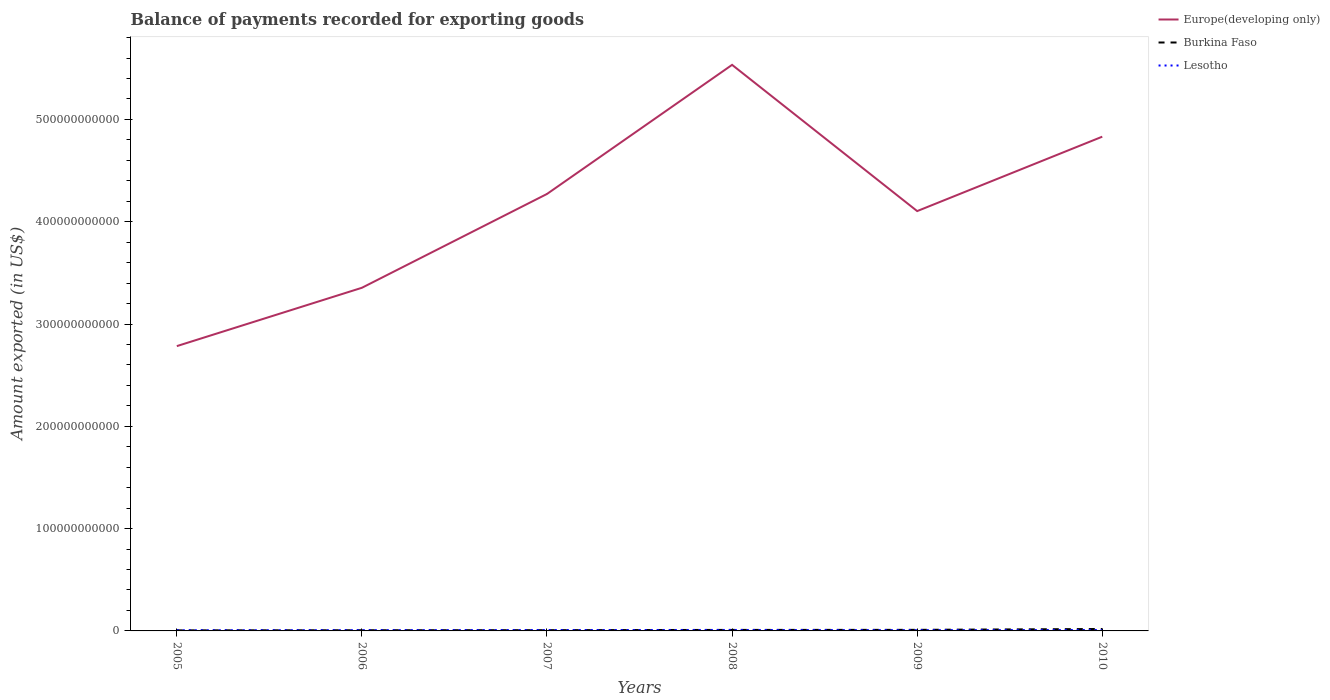Across all years, what is the maximum amount exported in Europe(developing only)?
Provide a short and direct response. 2.78e+11. In which year was the amount exported in Europe(developing only) maximum?
Keep it short and to the point. 2005. What is the total amount exported in Europe(developing only) in the graph?
Your answer should be compact. -5.70e+1. What is the difference between the highest and the second highest amount exported in Europe(developing only)?
Your answer should be very brief. 2.75e+11. Is the amount exported in Burkina Faso strictly greater than the amount exported in Europe(developing only) over the years?
Provide a short and direct response. Yes. How many lines are there?
Keep it short and to the point. 3. What is the difference between two consecutive major ticks on the Y-axis?
Your response must be concise. 1.00e+11. How many legend labels are there?
Ensure brevity in your answer.  3. How are the legend labels stacked?
Keep it short and to the point. Vertical. What is the title of the graph?
Offer a very short reply. Balance of payments recorded for exporting goods. Does "Korea (Republic)" appear as one of the legend labels in the graph?
Ensure brevity in your answer.  No. What is the label or title of the X-axis?
Make the answer very short. Years. What is the label or title of the Y-axis?
Make the answer very short. Amount exported (in US$). What is the Amount exported (in US$) in Europe(developing only) in 2005?
Keep it short and to the point. 2.78e+11. What is the Amount exported (in US$) in Burkina Faso in 2005?
Your answer should be very brief. 5.45e+08. What is the Amount exported (in US$) of Lesotho in 2005?
Your answer should be very brief. 6.68e+08. What is the Amount exported (in US$) in Europe(developing only) in 2006?
Offer a terse response. 3.35e+11. What is the Amount exported (in US$) in Burkina Faso in 2006?
Keep it short and to the point. 6.68e+08. What is the Amount exported (in US$) of Lesotho in 2006?
Offer a terse response. 7.57e+08. What is the Amount exported (in US$) of Europe(developing only) in 2007?
Ensure brevity in your answer.  4.27e+11. What is the Amount exported (in US$) in Burkina Faso in 2007?
Make the answer very short. 7.41e+08. What is the Amount exported (in US$) in Lesotho in 2007?
Your answer should be very brief. 8.72e+08. What is the Amount exported (in US$) in Europe(developing only) in 2008?
Provide a succinct answer. 5.53e+11. What is the Amount exported (in US$) in Burkina Faso in 2008?
Your response must be concise. 9.84e+08. What is the Amount exported (in US$) of Lesotho in 2008?
Give a very brief answer. 9.32e+08. What is the Amount exported (in US$) of Europe(developing only) in 2009?
Ensure brevity in your answer.  4.10e+11. What is the Amount exported (in US$) of Burkina Faso in 2009?
Your answer should be compact. 1.05e+09. What is the Amount exported (in US$) in Lesotho in 2009?
Keep it short and to the point. 7.76e+08. What is the Amount exported (in US$) in Europe(developing only) in 2010?
Your answer should be compact. 4.83e+11. What is the Amount exported (in US$) in Burkina Faso in 2010?
Provide a short and direct response. 1.89e+09. What is the Amount exported (in US$) of Lesotho in 2010?
Your response must be concise. 9.25e+08. Across all years, what is the maximum Amount exported (in US$) of Europe(developing only)?
Provide a short and direct response. 5.53e+11. Across all years, what is the maximum Amount exported (in US$) in Burkina Faso?
Ensure brevity in your answer.  1.89e+09. Across all years, what is the maximum Amount exported (in US$) in Lesotho?
Your response must be concise. 9.32e+08. Across all years, what is the minimum Amount exported (in US$) of Europe(developing only)?
Offer a terse response. 2.78e+11. Across all years, what is the minimum Amount exported (in US$) of Burkina Faso?
Give a very brief answer. 5.45e+08. Across all years, what is the minimum Amount exported (in US$) of Lesotho?
Your answer should be very brief. 6.68e+08. What is the total Amount exported (in US$) in Europe(developing only) in the graph?
Provide a short and direct response. 2.49e+12. What is the total Amount exported (in US$) in Burkina Faso in the graph?
Make the answer very short. 5.88e+09. What is the total Amount exported (in US$) of Lesotho in the graph?
Your response must be concise. 4.93e+09. What is the difference between the Amount exported (in US$) in Europe(developing only) in 2005 and that in 2006?
Your response must be concise. -5.70e+1. What is the difference between the Amount exported (in US$) in Burkina Faso in 2005 and that in 2006?
Offer a terse response. -1.22e+08. What is the difference between the Amount exported (in US$) of Lesotho in 2005 and that in 2006?
Your answer should be compact. -8.89e+07. What is the difference between the Amount exported (in US$) in Europe(developing only) in 2005 and that in 2007?
Your answer should be compact. -1.49e+11. What is the difference between the Amount exported (in US$) of Burkina Faso in 2005 and that in 2007?
Your answer should be very brief. -1.95e+08. What is the difference between the Amount exported (in US$) in Lesotho in 2005 and that in 2007?
Ensure brevity in your answer.  -2.04e+08. What is the difference between the Amount exported (in US$) in Europe(developing only) in 2005 and that in 2008?
Offer a terse response. -2.75e+11. What is the difference between the Amount exported (in US$) in Burkina Faso in 2005 and that in 2008?
Give a very brief answer. -4.39e+08. What is the difference between the Amount exported (in US$) in Lesotho in 2005 and that in 2008?
Your answer should be compact. -2.64e+08. What is the difference between the Amount exported (in US$) in Europe(developing only) in 2005 and that in 2009?
Make the answer very short. -1.32e+11. What is the difference between the Amount exported (in US$) of Burkina Faso in 2005 and that in 2009?
Keep it short and to the point. -5.08e+08. What is the difference between the Amount exported (in US$) of Lesotho in 2005 and that in 2009?
Ensure brevity in your answer.  -1.08e+08. What is the difference between the Amount exported (in US$) of Europe(developing only) in 2005 and that in 2010?
Your answer should be very brief. -2.05e+11. What is the difference between the Amount exported (in US$) of Burkina Faso in 2005 and that in 2010?
Provide a short and direct response. -1.34e+09. What is the difference between the Amount exported (in US$) in Lesotho in 2005 and that in 2010?
Give a very brief answer. -2.57e+08. What is the difference between the Amount exported (in US$) of Europe(developing only) in 2006 and that in 2007?
Provide a short and direct response. -9.17e+1. What is the difference between the Amount exported (in US$) of Burkina Faso in 2006 and that in 2007?
Offer a terse response. -7.29e+07. What is the difference between the Amount exported (in US$) in Lesotho in 2006 and that in 2007?
Provide a short and direct response. -1.15e+08. What is the difference between the Amount exported (in US$) of Europe(developing only) in 2006 and that in 2008?
Provide a short and direct response. -2.18e+11. What is the difference between the Amount exported (in US$) of Burkina Faso in 2006 and that in 2008?
Your response must be concise. -3.16e+08. What is the difference between the Amount exported (in US$) of Lesotho in 2006 and that in 2008?
Offer a terse response. -1.75e+08. What is the difference between the Amount exported (in US$) of Europe(developing only) in 2006 and that in 2009?
Make the answer very short. -7.50e+1. What is the difference between the Amount exported (in US$) of Burkina Faso in 2006 and that in 2009?
Give a very brief answer. -3.85e+08. What is the difference between the Amount exported (in US$) in Lesotho in 2006 and that in 2009?
Keep it short and to the point. -1.87e+07. What is the difference between the Amount exported (in US$) in Europe(developing only) in 2006 and that in 2010?
Ensure brevity in your answer.  -1.48e+11. What is the difference between the Amount exported (in US$) of Burkina Faso in 2006 and that in 2010?
Ensure brevity in your answer.  -1.22e+09. What is the difference between the Amount exported (in US$) of Lesotho in 2006 and that in 2010?
Provide a short and direct response. -1.68e+08. What is the difference between the Amount exported (in US$) in Europe(developing only) in 2007 and that in 2008?
Give a very brief answer. -1.26e+11. What is the difference between the Amount exported (in US$) in Burkina Faso in 2007 and that in 2008?
Make the answer very short. -2.43e+08. What is the difference between the Amount exported (in US$) of Lesotho in 2007 and that in 2008?
Give a very brief answer. -6.01e+07. What is the difference between the Amount exported (in US$) in Europe(developing only) in 2007 and that in 2009?
Your answer should be compact. 1.67e+1. What is the difference between the Amount exported (in US$) in Burkina Faso in 2007 and that in 2009?
Offer a very short reply. -3.12e+08. What is the difference between the Amount exported (in US$) in Lesotho in 2007 and that in 2009?
Provide a succinct answer. 9.66e+07. What is the difference between the Amount exported (in US$) in Europe(developing only) in 2007 and that in 2010?
Keep it short and to the point. -5.60e+1. What is the difference between the Amount exported (in US$) of Burkina Faso in 2007 and that in 2010?
Give a very brief answer. -1.15e+09. What is the difference between the Amount exported (in US$) of Lesotho in 2007 and that in 2010?
Offer a very short reply. -5.31e+07. What is the difference between the Amount exported (in US$) of Europe(developing only) in 2008 and that in 2009?
Give a very brief answer. 1.43e+11. What is the difference between the Amount exported (in US$) in Burkina Faso in 2008 and that in 2009?
Offer a terse response. -6.92e+07. What is the difference between the Amount exported (in US$) in Lesotho in 2008 and that in 2009?
Make the answer very short. 1.57e+08. What is the difference between the Amount exported (in US$) of Europe(developing only) in 2008 and that in 2010?
Provide a succinct answer. 7.02e+1. What is the difference between the Amount exported (in US$) in Burkina Faso in 2008 and that in 2010?
Offer a terse response. -9.05e+08. What is the difference between the Amount exported (in US$) of Lesotho in 2008 and that in 2010?
Provide a succinct answer. 7.00e+06. What is the difference between the Amount exported (in US$) of Europe(developing only) in 2009 and that in 2010?
Provide a succinct answer. -7.27e+1. What is the difference between the Amount exported (in US$) in Burkina Faso in 2009 and that in 2010?
Offer a very short reply. -8.36e+08. What is the difference between the Amount exported (in US$) in Lesotho in 2009 and that in 2010?
Provide a succinct answer. -1.50e+08. What is the difference between the Amount exported (in US$) in Europe(developing only) in 2005 and the Amount exported (in US$) in Burkina Faso in 2006?
Offer a very short reply. 2.78e+11. What is the difference between the Amount exported (in US$) in Europe(developing only) in 2005 and the Amount exported (in US$) in Lesotho in 2006?
Give a very brief answer. 2.78e+11. What is the difference between the Amount exported (in US$) in Burkina Faso in 2005 and the Amount exported (in US$) in Lesotho in 2006?
Keep it short and to the point. -2.12e+08. What is the difference between the Amount exported (in US$) in Europe(developing only) in 2005 and the Amount exported (in US$) in Burkina Faso in 2007?
Keep it short and to the point. 2.78e+11. What is the difference between the Amount exported (in US$) of Europe(developing only) in 2005 and the Amount exported (in US$) of Lesotho in 2007?
Offer a very short reply. 2.78e+11. What is the difference between the Amount exported (in US$) in Burkina Faso in 2005 and the Amount exported (in US$) in Lesotho in 2007?
Your answer should be compact. -3.27e+08. What is the difference between the Amount exported (in US$) of Europe(developing only) in 2005 and the Amount exported (in US$) of Burkina Faso in 2008?
Offer a very short reply. 2.77e+11. What is the difference between the Amount exported (in US$) in Europe(developing only) in 2005 and the Amount exported (in US$) in Lesotho in 2008?
Make the answer very short. 2.77e+11. What is the difference between the Amount exported (in US$) of Burkina Faso in 2005 and the Amount exported (in US$) of Lesotho in 2008?
Your response must be concise. -3.87e+08. What is the difference between the Amount exported (in US$) of Europe(developing only) in 2005 and the Amount exported (in US$) of Burkina Faso in 2009?
Offer a terse response. 2.77e+11. What is the difference between the Amount exported (in US$) of Europe(developing only) in 2005 and the Amount exported (in US$) of Lesotho in 2009?
Offer a very short reply. 2.78e+11. What is the difference between the Amount exported (in US$) in Burkina Faso in 2005 and the Amount exported (in US$) in Lesotho in 2009?
Your response must be concise. -2.30e+08. What is the difference between the Amount exported (in US$) of Europe(developing only) in 2005 and the Amount exported (in US$) of Burkina Faso in 2010?
Your answer should be compact. 2.76e+11. What is the difference between the Amount exported (in US$) of Europe(developing only) in 2005 and the Amount exported (in US$) of Lesotho in 2010?
Provide a short and direct response. 2.77e+11. What is the difference between the Amount exported (in US$) of Burkina Faso in 2005 and the Amount exported (in US$) of Lesotho in 2010?
Provide a succinct answer. -3.80e+08. What is the difference between the Amount exported (in US$) in Europe(developing only) in 2006 and the Amount exported (in US$) in Burkina Faso in 2007?
Ensure brevity in your answer.  3.35e+11. What is the difference between the Amount exported (in US$) of Europe(developing only) in 2006 and the Amount exported (in US$) of Lesotho in 2007?
Provide a succinct answer. 3.35e+11. What is the difference between the Amount exported (in US$) of Burkina Faso in 2006 and the Amount exported (in US$) of Lesotho in 2007?
Provide a succinct answer. -2.05e+08. What is the difference between the Amount exported (in US$) in Europe(developing only) in 2006 and the Amount exported (in US$) in Burkina Faso in 2008?
Make the answer very short. 3.34e+11. What is the difference between the Amount exported (in US$) of Europe(developing only) in 2006 and the Amount exported (in US$) of Lesotho in 2008?
Provide a succinct answer. 3.34e+11. What is the difference between the Amount exported (in US$) of Burkina Faso in 2006 and the Amount exported (in US$) of Lesotho in 2008?
Offer a very short reply. -2.65e+08. What is the difference between the Amount exported (in US$) of Europe(developing only) in 2006 and the Amount exported (in US$) of Burkina Faso in 2009?
Offer a terse response. 3.34e+11. What is the difference between the Amount exported (in US$) in Europe(developing only) in 2006 and the Amount exported (in US$) in Lesotho in 2009?
Provide a short and direct response. 3.35e+11. What is the difference between the Amount exported (in US$) of Burkina Faso in 2006 and the Amount exported (in US$) of Lesotho in 2009?
Give a very brief answer. -1.08e+08. What is the difference between the Amount exported (in US$) in Europe(developing only) in 2006 and the Amount exported (in US$) in Burkina Faso in 2010?
Provide a short and direct response. 3.34e+11. What is the difference between the Amount exported (in US$) of Europe(developing only) in 2006 and the Amount exported (in US$) of Lesotho in 2010?
Make the answer very short. 3.34e+11. What is the difference between the Amount exported (in US$) of Burkina Faso in 2006 and the Amount exported (in US$) of Lesotho in 2010?
Your answer should be very brief. -2.58e+08. What is the difference between the Amount exported (in US$) in Europe(developing only) in 2007 and the Amount exported (in US$) in Burkina Faso in 2008?
Ensure brevity in your answer.  4.26e+11. What is the difference between the Amount exported (in US$) of Europe(developing only) in 2007 and the Amount exported (in US$) of Lesotho in 2008?
Provide a short and direct response. 4.26e+11. What is the difference between the Amount exported (in US$) of Burkina Faso in 2007 and the Amount exported (in US$) of Lesotho in 2008?
Your answer should be compact. -1.92e+08. What is the difference between the Amount exported (in US$) of Europe(developing only) in 2007 and the Amount exported (in US$) of Burkina Faso in 2009?
Provide a short and direct response. 4.26e+11. What is the difference between the Amount exported (in US$) in Europe(developing only) in 2007 and the Amount exported (in US$) in Lesotho in 2009?
Give a very brief answer. 4.26e+11. What is the difference between the Amount exported (in US$) of Burkina Faso in 2007 and the Amount exported (in US$) of Lesotho in 2009?
Provide a short and direct response. -3.51e+07. What is the difference between the Amount exported (in US$) of Europe(developing only) in 2007 and the Amount exported (in US$) of Burkina Faso in 2010?
Make the answer very short. 4.25e+11. What is the difference between the Amount exported (in US$) of Europe(developing only) in 2007 and the Amount exported (in US$) of Lesotho in 2010?
Ensure brevity in your answer.  4.26e+11. What is the difference between the Amount exported (in US$) in Burkina Faso in 2007 and the Amount exported (in US$) in Lesotho in 2010?
Offer a very short reply. -1.85e+08. What is the difference between the Amount exported (in US$) of Europe(developing only) in 2008 and the Amount exported (in US$) of Burkina Faso in 2009?
Your answer should be very brief. 5.52e+11. What is the difference between the Amount exported (in US$) in Europe(developing only) in 2008 and the Amount exported (in US$) in Lesotho in 2009?
Ensure brevity in your answer.  5.53e+11. What is the difference between the Amount exported (in US$) of Burkina Faso in 2008 and the Amount exported (in US$) of Lesotho in 2009?
Offer a terse response. 2.08e+08. What is the difference between the Amount exported (in US$) in Europe(developing only) in 2008 and the Amount exported (in US$) in Burkina Faso in 2010?
Your answer should be very brief. 5.51e+11. What is the difference between the Amount exported (in US$) of Europe(developing only) in 2008 and the Amount exported (in US$) of Lesotho in 2010?
Offer a terse response. 5.52e+11. What is the difference between the Amount exported (in US$) of Burkina Faso in 2008 and the Amount exported (in US$) of Lesotho in 2010?
Make the answer very short. 5.85e+07. What is the difference between the Amount exported (in US$) in Europe(developing only) in 2009 and the Amount exported (in US$) in Burkina Faso in 2010?
Provide a short and direct response. 4.08e+11. What is the difference between the Amount exported (in US$) in Europe(developing only) in 2009 and the Amount exported (in US$) in Lesotho in 2010?
Offer a terse response. 4.09e+11. What is the difference between the Amount exported (in US$) of Burkina Faso in 2009 and the Amount exported (in US$) of Lesotho in 2010?
Keep it short and to the point. 1.28e+08. What is the average Amount exported (in US$) of Europe(developing only) per year?
Your answer should be very brief. 4.15e+11. What is the average Amount exported (in US$) of Burkina Faso per year?
Provide a succinct answer. 9.80e+08. What is the average Amount exported (in US$) of Lesotho per year?
Keep it short and to the point. 8.22e+08. In the year 2005, what is the difference between the Amount exported (in US$) of Europe(developing only) and Amount exported (in US$) of Burkina Faso?
Give a very brief answer. 2.78e+11. In the year 2005, what is the difference between the Amount exported (in US$) of Europe(developing only) and Amount exported (in US$) of Lesotho?
Keep it short and to the point. 2.78e+11. In the year 2005, what is the difference between the Amount exported (in US$) in Burkina Faso and Amount exported (in US$) in Lesotho?
Offer a terse response. -1.23e+08. In the year 2006, what is the difference between the Amount exported (in US$) of Europe(developing only) and Amount exported (in US$) of Burkina Faso?
Your answer should be compact. 3.35e+11. In the year 2006, what is the difference between the Amount exported (in US$) of Europe(developing only) and Amount exported (in US$) of Lesotho?
Offer a terse response. 3.35e+11. In the year 2006, what is the difference between the Amount exported (in US$) of Burkina Faso and Amount exported (in US$) of Lesotho?
Your answer should be compact. -8.93e+07. In the year 2007, what is the difference between the Amount exported (in US$) in Europe(developing only) and Amount exported (in US$) in Burkina Faso?
Offer a terse response. 4.26e+11. In the year 2007, what is the difference between the Amount exported (in US$) of Europe(developing only) and Amount exported (in US$) of Lesotho?
Provide a short and direct response. 4.26e+11. In the year 2007, what is the difference between the Amount exported (in US$) of Burkina Faso and Amount exported (in US$) of Lesotho?
Your response must be concise. -1.32e+08. In the year 2008, what is the difference between the Amount exported (in US$) of Europe(developing only) and Amount exported (in US$) of Burkina Faso?
Make the answer very short. 5.52e+11. In the year 2008, what is the difference between the Amount exported (in US$) in Europe(developing only) and Amount exported (in US$) in Lesotho?
Offer a very short reply. 5.52e+11. In the year 2008, what is the difference between the Amount exported (in US$) in Burkina Faso and Amount exported (in US$) in Lesotho?
Give a very brief answer. 5.15e+07. In the year 2009, what is the difference between the Amount exported (in US$) in Europe(developing only) and Amount exported (in US$) in Burkina Faso?
Give a very brief answer. 4.09e+11. In the year 2009, what is the difference between the Amount exported (in US$) in Europe(developing only) and Amount exported (in US$) in Lesotho?
Your answer should be very brief. 4.10e+11. In the year 2009, what is the difference between the Amount exported (in US$) in Burkina Faso and Amount exported (in US$) in Lesotho?
Your response must be concise. 2.77e+08. In the year 2010, what is the difference between the Amount exported (in US$) in Europe(developing only) and Amount exported (in US$) in Burkina Faso?
Your answer should be very brief. 4.81e+11. In the year 2010, what is the difference between the Amount exported (in US$) of Europe(developing only) and Amount exported (in US$) of Lesotho?
Make the answer very short. 4.82e+11. In the year 2010, what is the difference between the Amount exported (in US$) of Burkina Faso and Amount exported (in US$) of Lesotho?
Your answer should be very brief. 9.64e+08. What is the ratio of the Amount exported (in US$) in Europe(developing only) in 2005 to that in 2006?
Keep it short and to the point. 0.83. What is the ratio of the Amount exported (in US$) of Burkina Faso in 2005 to that in 2006?
Your answer should be very brief. 0.82. What is the ratio of the Amount exported (in US$) in Lesotho in 2005 to that in 2006?
Keep it short and to the point. 0.88. What is the ratio of the Amount exported (in US$) in Europe(developing only) in 2005 to that in 2007?
Give a very brief answer. 0.65. What is the ratio of the Amount exported (in US$) of Burkina Faso in 2005 to that in 2007?
Make the answer very short. 0.74. What is the ratio of the Amount exported (in US$) of Lesotho in 2005 to that in 2007?
Offer a very short reply. 0.77. What is the ratio of the Amount exported (in US$) of Europe(developing only) in 2005 to that in 2008?
Offer a very short reply. 0.5. What is the ratio of the Amount exported (in US$) in Burkina Faso in 2005 to that in 2008?
Offer a terse response. 0.55. What is the ratio of the Amount exported (in US$) in Lesotho in 2005 to that in 2008?
Offer a very short reply. 0.72. What is the ratio of the Amount exported (in US$) of Europe(developing only) in 2005 to that in 2009?
Your answer should be compact. 0.68. What is the ratio of the Amount exported (in US$) in Burkina Faso in 2005 to that in 2009?
Make the answer very short. 0.52. What is the ratio of the Amount exported (in US$) of Lesotho in 2005 to that in 2009?
Offer a terse response. 0.86. What is the ratio of the Amount exported (in US$) in Europe(developing only) in 2005 to that in 2010?
Give a very brief answer. 0.58. What is the ratio of the Amount exported (in US$) in Burkina Faso in 2005 to that in 2010?
Keep it short and to the point. 0.29. What is the ratio of the Amount exported (in US$) in Lesotho in 2005 to that in 2010?
Give a very brief answer. 0.72. What is the ratio of the Amount exported (in US$) of Europe(developing only) in 2006 to that in 2007?
Provide a short and direct response. 0.79. What is the ratio of the Amount exported (in US$) of Burkina Faso in 2006 to that in 2007?
Ensure brevity in your answer.  0.9. What is the ratio of the Amount exported (in US$) in Lesotho in 2006 to that in 2007?
Your response must be concise. 0.87. What is the ratio of the Amount exported (in US$) of Europe(developing only) in 2006 to that in 2008?
Your response must be concise. 0.61. What is the ratio of the Amount exported (in US$) in Burkina Faso in 2006 to that in 2008?
Your answer should be compact. 0.68. What is the ratio of the Amount exported (in US$) of Lesotho in 2006 to that in 2008?
Your response must be concise. 0.81. What is the ratio of the Amount exported (in US$) in Europe(developing only) in 2006 to that in 2009?
Your answer should be compact. 0.82. What is the ratio of the Amount exported (in US$) in Burkina Faso in 2006 to that in 2009?
Provide a short and direct response. 0.63. What is the ratio of the Amount exported (in US$) in Lesotho in 2006 to that in 2009?
Make the answer very short. 0.98. What is the ratio of the Amount exported (in US$) of Europe(developing only) in 2006 to that in 2010?
Your answer should be very brief. 0.69. What is the ratio of the Amount exported (in US$) of Burkina Faso in 2006 to that in 2010?
Your response must be concise. 0.35. What is the ratio of the Amount exported (in US$) of Lesotho in 2006 to that in 2010?
Ensure brevity in your answer.  0.82. What is the ratio of the Amount exported (in US$) in Europe(developing only) in 2007 to that in 2008?
Offer a very short reply. 0.77. What is the ratio of the Amount exported (in US$) in Burkina Faso in 2007 to that in 2008?
Ensure brevity in your answer.  0.75. What is the ratio of the Amount exported (in US$) of Lesotho in 2007 to that in 2008?
Make the answer very short. 0.94. What is the ratio of the Amount exported (in US$) in Europe(developing only) in 2007 to that in 2009?
Ensure brevity in your answer.  1.04. What is the ratio of the Amount exported (in US$) of Burkina Faso in 2007 to that in 2009?
Offer a very short reply. 0.7. What is the ratio of the Amount exported (in US$) in Lesotho in 2007 to that in 2009?
Provide a short and direct response. 1.12. What is the ratio of the Amount exported (in US$) of Europe(developing only) in 2007 to that in 2010?
Give a very brief answer. 0.88. What is the ratio of the Amount exported (in US$) of Burkina Faso in 2007 to that in 2010?
Provide a succinct answer. 0.39. What is the ratio of the Amount exported (in US$) of Lesotho in 2007 to that in 2010?
Ensure brevity in your answer.  0.94. What is the ratio of the Amount exported (in US$) in Europe(developing only) in 2008 to that in 2009?
Keep it short and to the point. 1.35. What is the ratio of the Amount exported (in US$) of Burkina Faso in 2008 to that in 2009?
Your answer should be compact. 0.93. What is the ratio of the Amount exported (in US$) in Lesotho in 2008 to that in 2009?
Give a very brief answer. 1.2. What is the ratio of the Amount exported (in US$) of Europe(developing only) in 2008 to that in 2010?
Your answer should be very brief. 1.15. What is the ratio of the Amount exported (in US$) of Burkina Faso in 2008 to that in 2010?
Your answer should be compact. 0.52. What is the ratio of the Amount exported (in US$) in Lesotho in 2008 to that in 2010?
Keep it short and to the point. 1.01. What is the ratio of the Amount exported (in US$) of Europe(developing only) in 2009 to that in 2010?
Your answer should be very brief. 0.85. What is the ratio of the Amount exported (in US$) of Burkina Faso in 2009 to that in 2010?
Your answer should be compact. 0.56. What is the ratio of the Amount exported (in US$) in Lesotho in 2009 to that in 2010?
Offer a very short reply. 0.84. What is the difference between the highest and the second highest Amount exported (in US$) in Europe(developing only)?
Ensure brevity in your answer.  7.02e+1. What is the difference between the highest and the second highest Amount exported (in US$) in Burkina Faso?
Your response must be concise. 8.36e+08. What is the difference between the highest and the second highest Amount exported (in US$) in Lesotho?
Offer a terse response. 7.00e+06. What is the difference between the highest and the lowest Amount exported (in US$) in Europe(developing only)?
Make the answer very short. 2.75e+11. What is the difference between the highest and the lowest Amount exported (in US$) of Burkina Faso?
Your answer should be compact. 1.34e+09. What is the difference between the highest and the lowest Amount exported (in US$) in Lesotho?
Provide a succinct answer. 2.64e+08. 